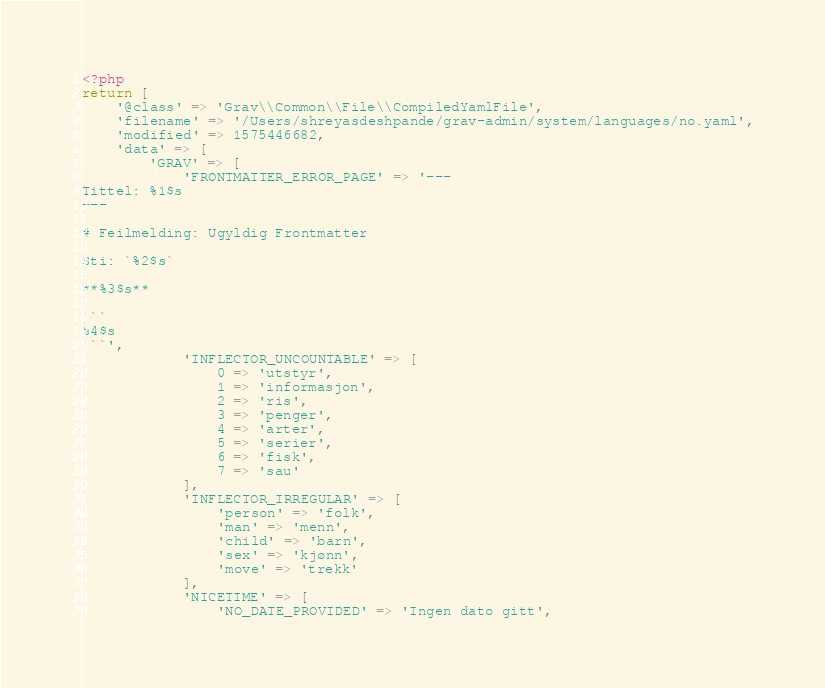Convert code to text. <code><loc_0><loc_0><loc_500><loc_500><_PHP_><?php
return [
    '@class' => 'Grav\\Common\\File\\CompiledYamlFile',
    'filename' => '/Users/shreyasdeshpande/grav-admin/system/languages/no.yaml',
    'modified' => 1575446682,
    'data' => [
        'GRAV' => [
            'FRONTMATTER_ERROR_PAGE' => '---
Tittel: %1$s
---

# Feilmelding: Ugyldig Frontmatter

Sti: `%2$s`

**%3$s**

```
%4$s
```',
            'INFLECTOR_UNCOUNTABLE' => [
                0 => 'utstyr',
                1 => 'informasjon',
                2 => 'ris',
                3 => 'penger',
                4 => 'arter',
                5 => 'serier',
                6 => 'fisk',
                7 => 'sau'
            ],
            'INFLECTOR_IRREGULAR' => [
                'person' => 'folk',
                'man' => 'menn',
                'child' => 'barn',
                'sex' => 'kjønn',
                'move' => 'trekk'
            ],
            'NICETIME' => [
                'NO_DATE_PROVIDED' => 'Ingen dato gitt',</code> 